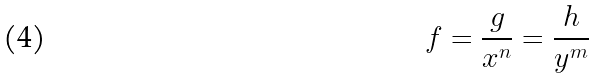<formula> <loc_0><loc_0><loc_500><loc_500>f = \frac { g } { x ^ { n } } = \frac { h } { y ^ { m } }</formula> 